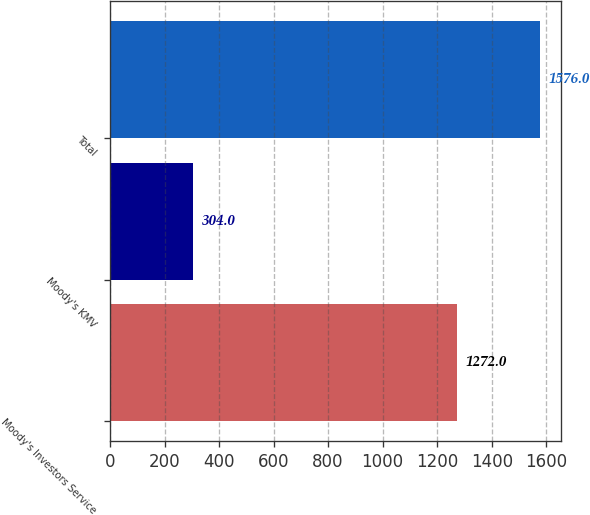<chart> <loc_0><loc_0><loc_500><loc_500><bar_chart><fcel>Moody's Investors Service<fcel>Moody's KMV<fcel>Total<nl><fcel>1272<fcel>304<fcel>1576<nl></chart> 